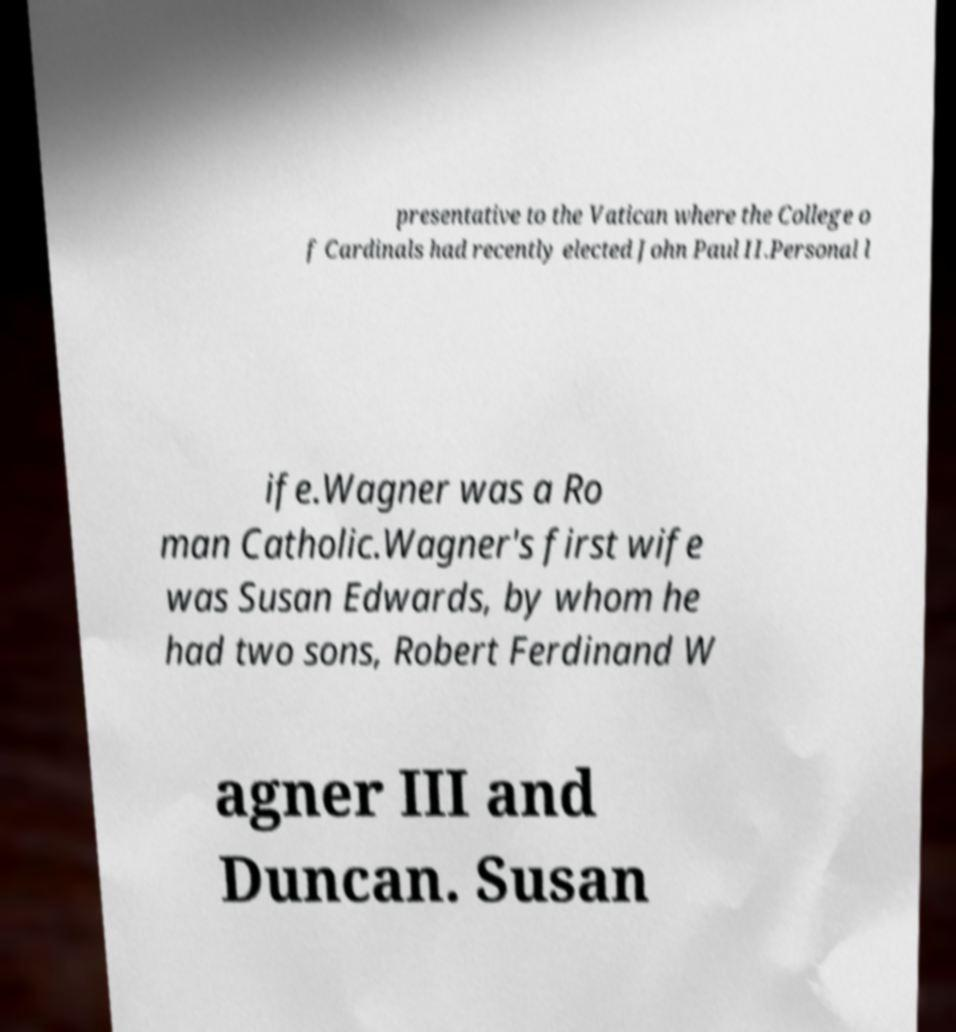Please identify and transcribe the text found in this image. presentative to the Vatican where the College o f Cardinals had recently elected John Paul II.Personal l ife.Wagner was a Ro man Catholic.Wagner's first wife was Susan Edwards, by whom he had two sons, Robert Ferdinand W agner III and Duncan. Susan 